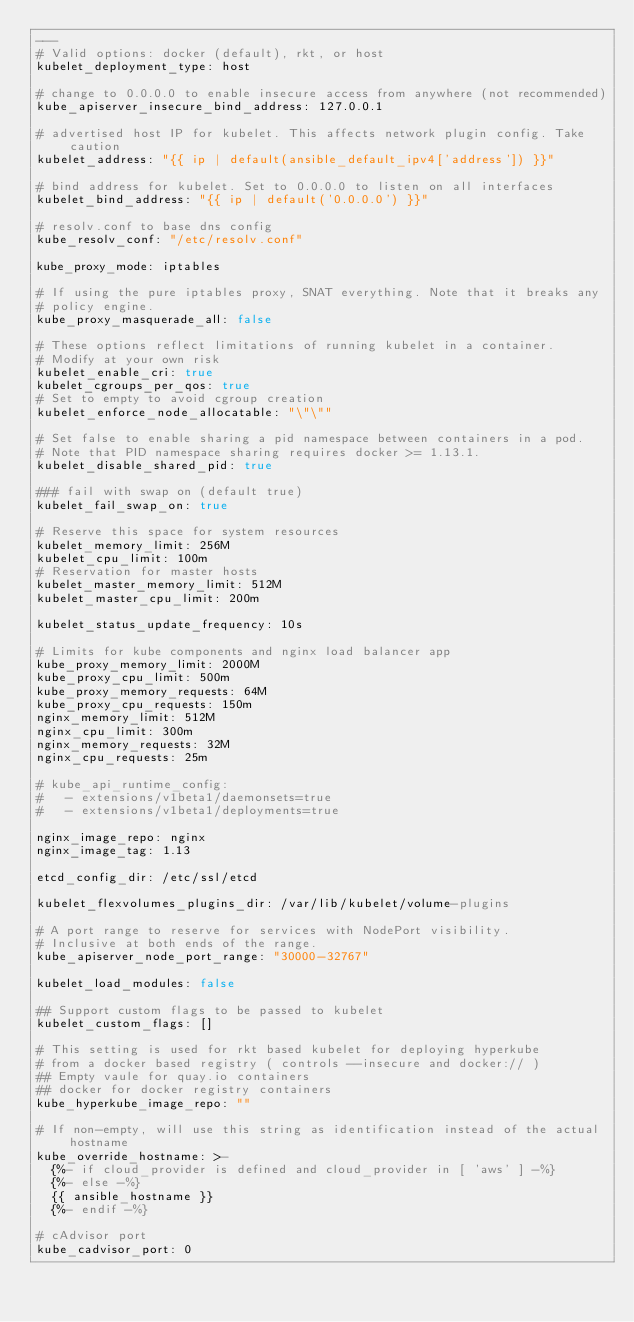Convert code to text. <code><loc_0><loc_0><loc_500><loc_500><_YAML_>---
# Valid options: docker (default), rkt, or host
kubelet_deployment_type: host

# change to 0.0.0.0 to enable insecure access from anywhere (not recommended)
kube_apiserver_insecure_bind_address: 127.0.0.1

# advertised host IP for kubelet. This affects network plugin config. Take caution
kubelet_address: "{{ ip | default(ansible_default_ipv4['address']) }}"

# bind address for kubelet. Set to 0.0.0.0 to listen on all interfaces
kubelet_bind_address: "{{ ip | default('0.0.0.0') }}"

# resolv.conf to base dns config
kube_resolv_conf: "/etc/resolv.conf"

kube_proxy_mode: iptables

# If using the pure iptables proxy, SNAT everything. Note that it breaks any
# policy engine.
kube_proxy_masquerade_all: false

# These options reflect limitations of running kubelet in a container.
# Modify at your own risk
kubelet_enable_cri: true
kubelet_cgroups_per_qos: true
# Set to empty to avoid cgroup creation
kubelet_enforce_node_allocatable: "\"\""

# Set false to enable sharing a pid namespace between containers in a pod.
# Note that PID namespace sharing requires docker >= 1.13.1.
kubelet_disable_shared_pid: true

### fail with swap on (default true)
kubelet_fail_swap_on: true

# Reserve this space for system resources
kubelet_memory_limit: 256M
kubelet_cpu_limit: 100m
# Reservation for master hosts
kubelet_master_memory_limit: 512M
kubelet_master_cpu_limit: 200m

kubelet_status_update_frequency: 10s

# Limits for kube components and nginx load balancer app
kube_proxy_memory_limit: 2000M
kube_proxy_cpu_limit: 500m
kube_proxy_memory_requests: 64M
kube_proxy_cpu_requests: 150m
nginx_memory_limit: 512M
nginx_cpu_limit: 300m
nginx_memory_requests: 32M
nginx_cpu_requests: 25m

# kube_api_runtime_config:
#   - extensions/v1beta1/daemonsets=true
#   - extensions/v1beta1/deployments=true

nginx_image_repo: nginx
nginx_image_tag: 1.13

etcd_config_dir: /etc/ssl/etcd

kubelet_flexvolumes_plugins_dir: /var/lib/kubelet/volume-plugins

# A port range to reserve for services with NodePort visibility.
# Inclusive at both ends of the range.
kube_apiserver_node_port_range: "30000-32767"

kubelet_load_modules: false

## Support custom flags to be passed to kubelet
kubelet_custom_flags: []

# This setting is used for rkt based kubelet for deploying hyperkube
# from a docker based registry ( controls --insecure and docker:// )
## Empty vaule for quay.io containers
## docker for docker registry containers
kube_hyperkube_image_repo: ""

# If non-empty, will use this string as identification instead of the actual hostname
kube_override_hostname: >-
  {%- if cloud_provider is defined and cloud_provider in [ 'aws' ] -%}
  {%- else -%}
  {{ ansible_hostname }}
  {%- endif -%}

# cAdvisor port
kube_cadvisor_port: 0
</code> 